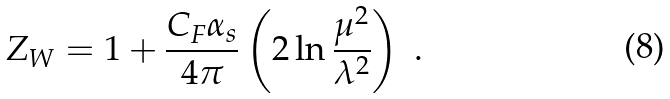<formula> <loc_0><loc_0><loc_500><loc_500>Z _ { W } = 1 + \frac { C _ { F } \alpha _ { s } } { 4 \pi } \left ( 2 \ln \frac { \mu ^ { 2 } } { \lambda ^ { 2 } } \right ) \ .</formula> 